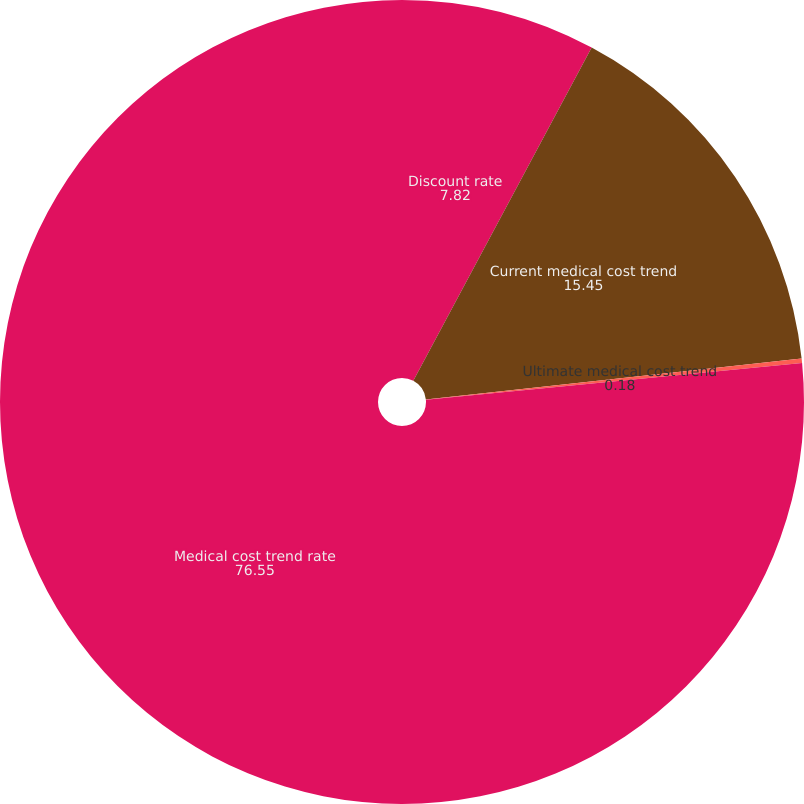Convert chart to OTSL. <chart><loc_0><loc_0><loc_500><loc_500><pie_chart><fcel>Discount rate<fcel>Current medical cost trend<fcel>Ultimate medical cost trend<fcel>Medical cost trend rate<nl><fcel>7.82%<fcel>15.45%<fcel>0.18%<fcel>76.55%<nl></chart> 